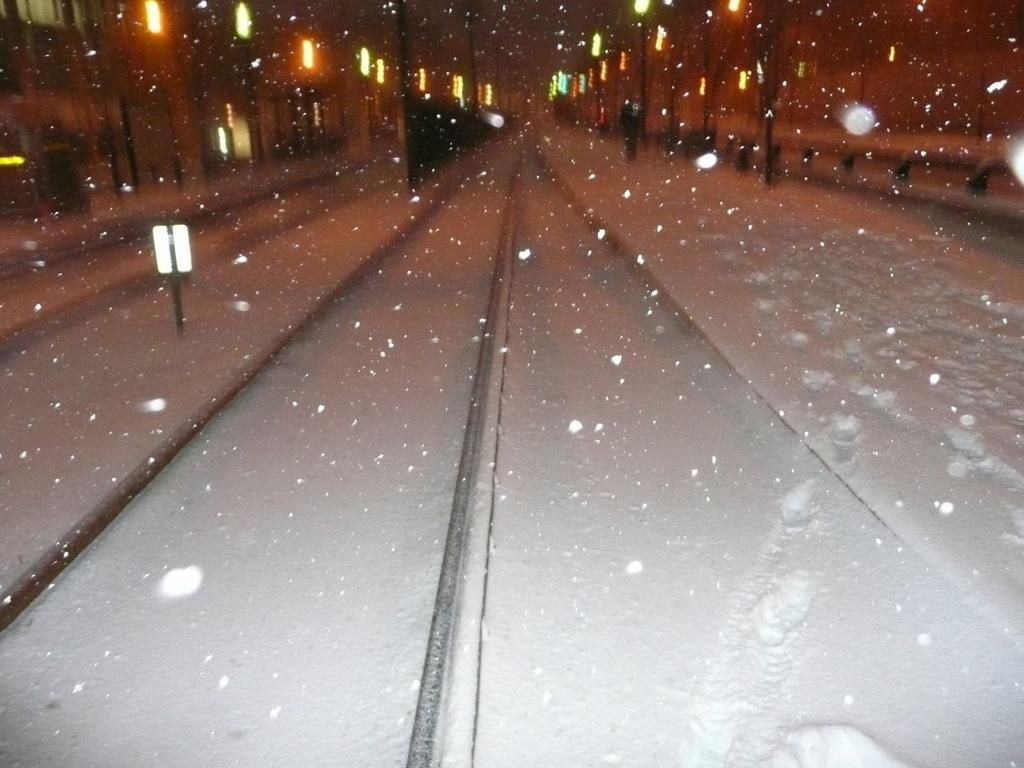What type of weather condition is depicted in the image? The surface in the image has snow, indicating a snowy weather condition. What can be seen on the snowy surface? There are railway tracks on the snowy surface. Are there any structures or objects near the railway tracks? Yes, there are poles with lights on both sides of the railway tracks. What type of protest is taking place near the railway tracks in the image? There is no protest taking place in the image; it only shows railway tracks, snow, and poles with lights. Can you tell me what date is marked on the calendar in the image? There is no calendar present in the image. 